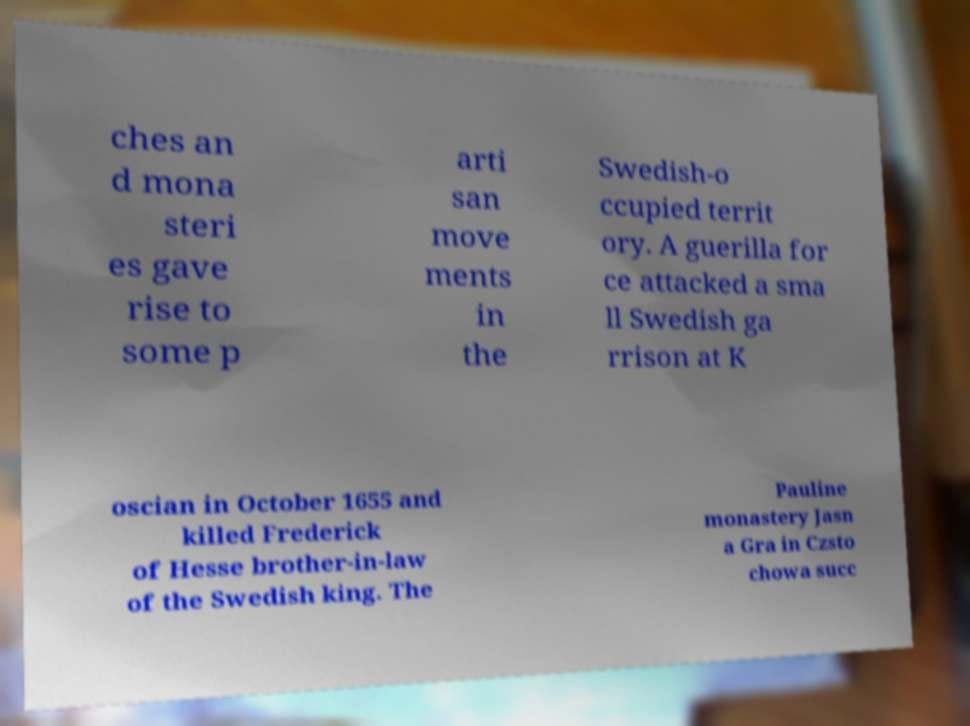For documentation purposes, I need the text within this image transcribed. Could you provide that? ches an d mona steri es gave rise to some p arti san move ments in the Swedish-o ccupied territ ory. A guerilla for ce attacked a sma ll Swedish ga rrison at K oscian in October 1655 and killed Frederick of Hesse brother-in-law of the Swedish king. The Pauline monastery Jasn a Gra in Czsto chowa succ 